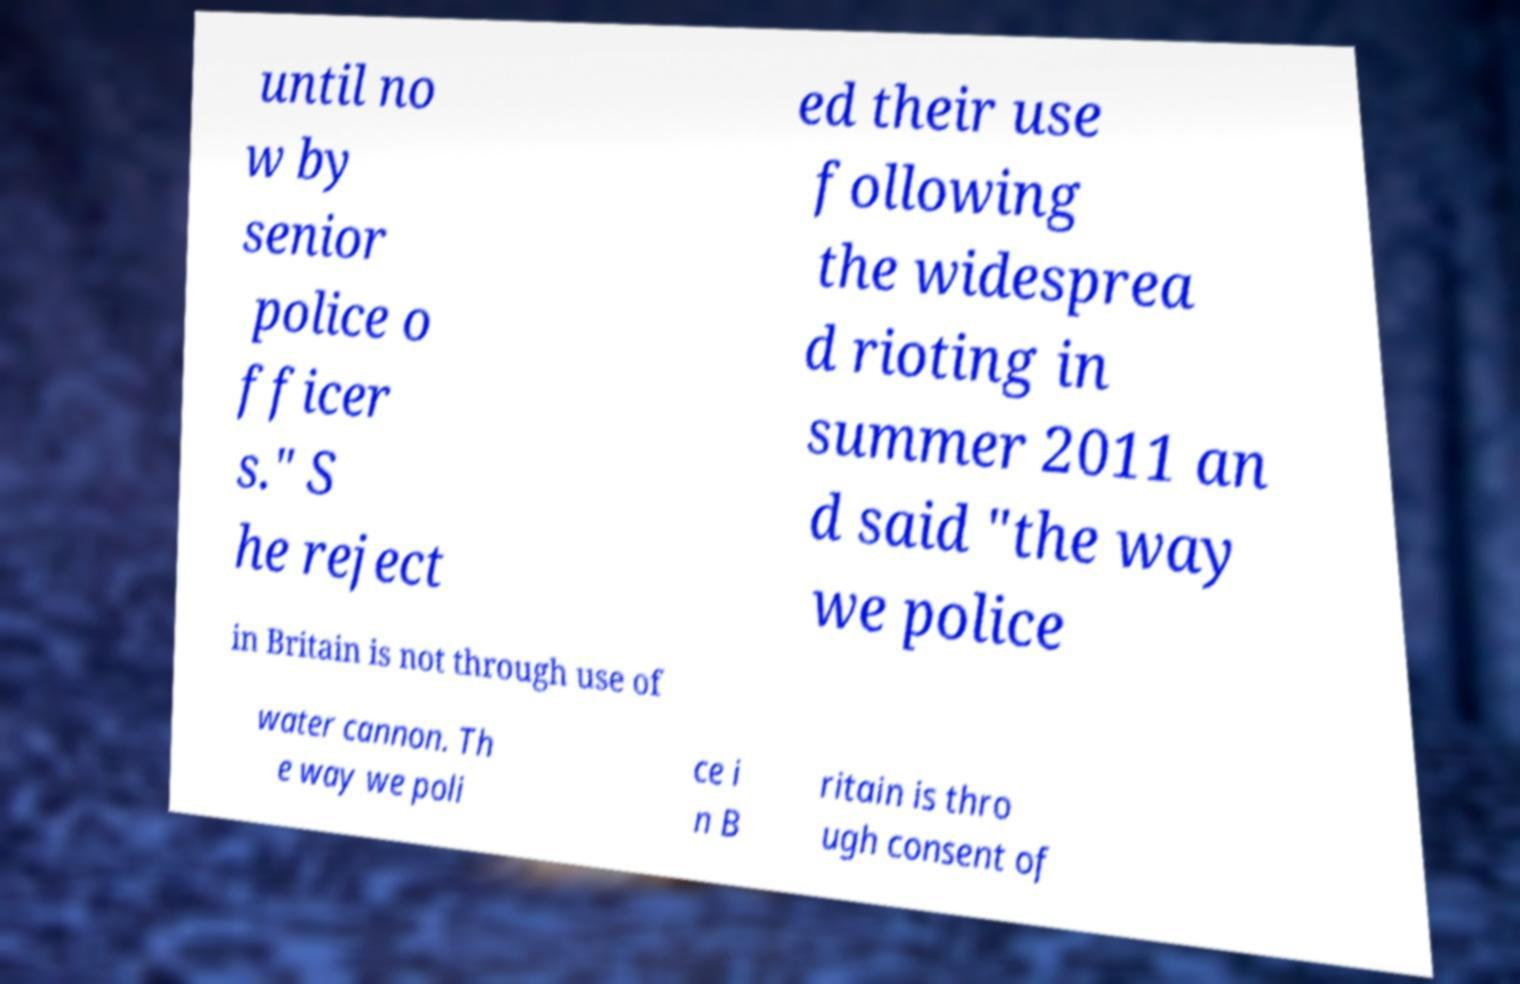Please identify and transcribe the text found in this image. until no w by senior police o fficer s." S he reject ed their use following the widesprea d rioting in summer 2011 an d said "the way we police in Britain is not through use of water cannon. Th e way we poli ce i n B ritain is thro ugh consent of 